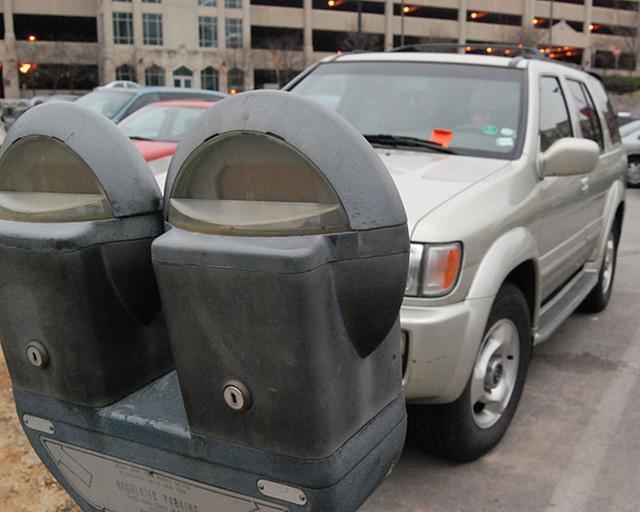How many parking meters can you see?
Give a very brief answer. 2. How many cars are in the photo?
Give a very brief answer. 3. 